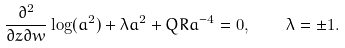Convert formula to latex. <formula><loc_0><loc_0><loc_500><loc_500>\frac { \partial ^ { 2 } } { \partial z \partial w } \log ( a ^ { 2 } ) + \lambda a ^ { 2 } + Q R a ^ { - 4 } = 0 , \quad \lambda = \pm 1 .</formula> 